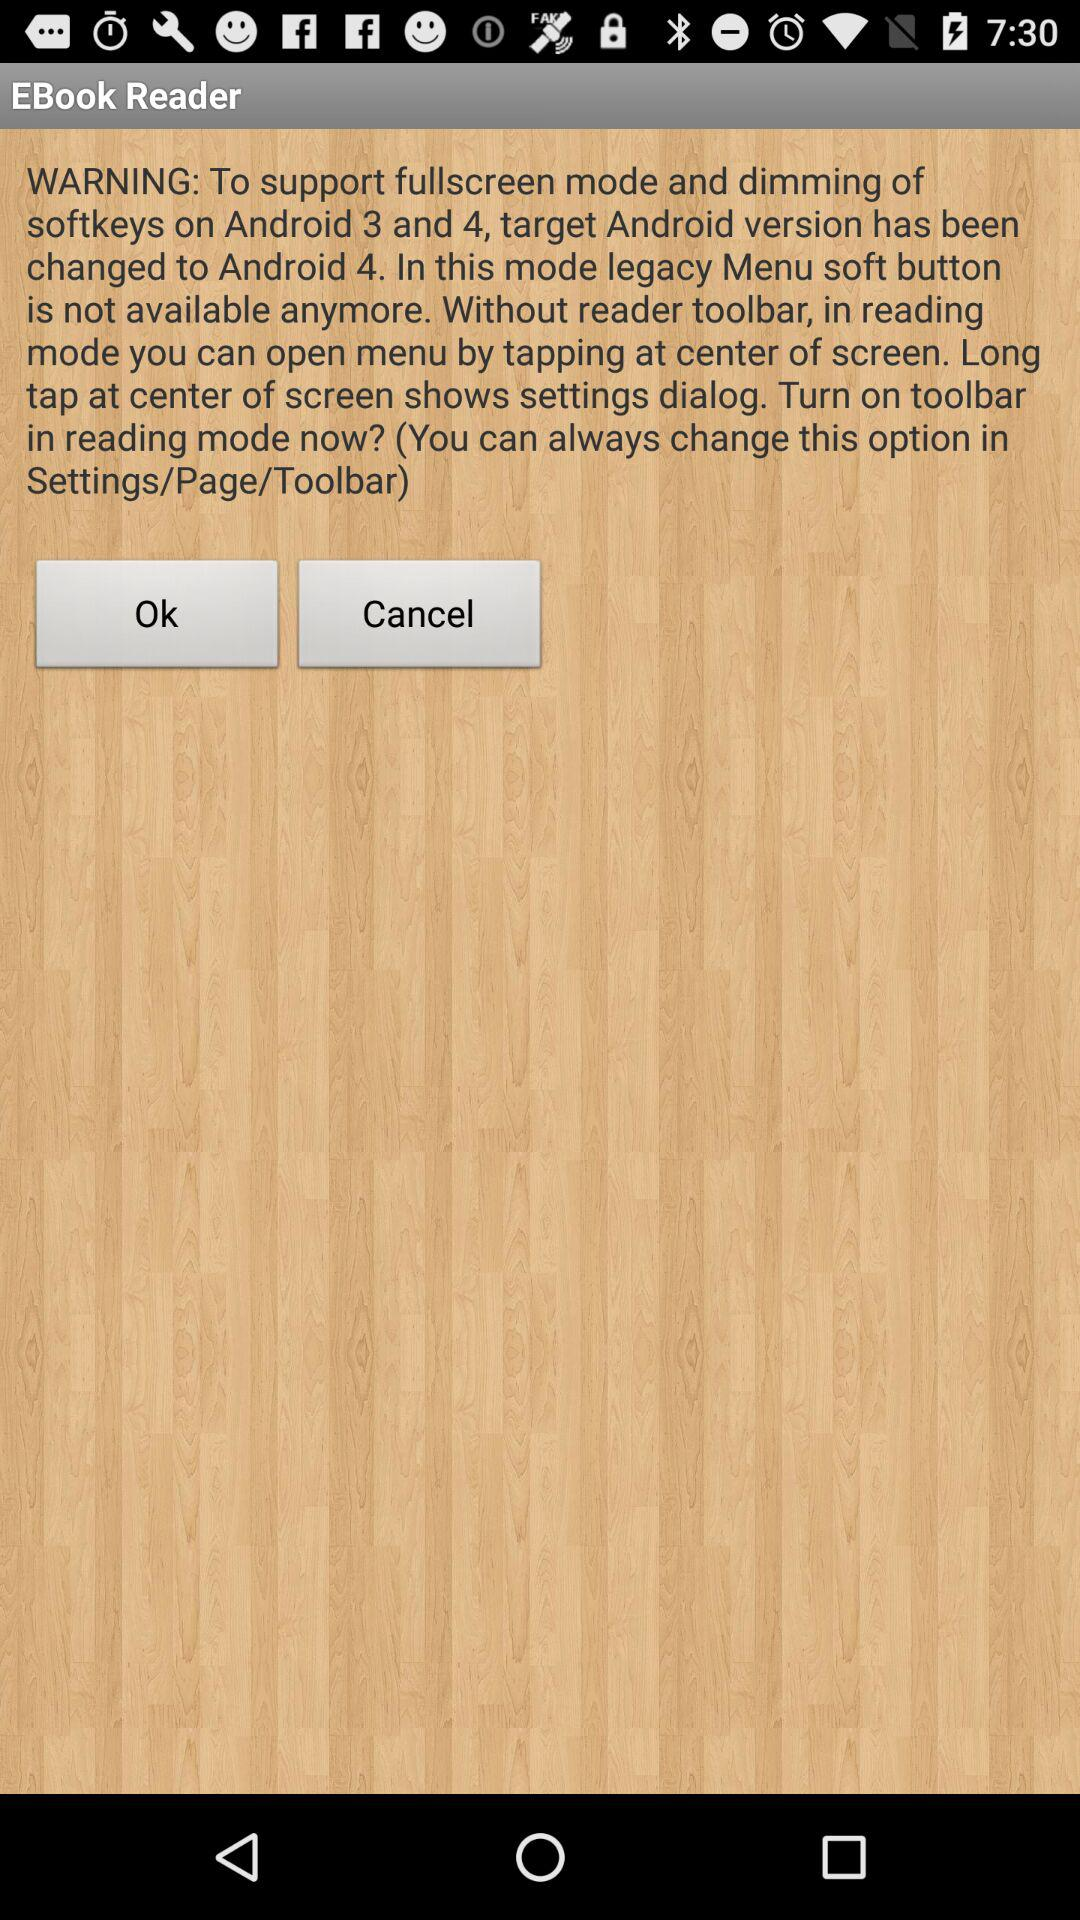Which Android version supports fullscreen mode and dimming of softkeys? The Android version that supports fullscreen mode and dimming of softkeys is Android 4. 